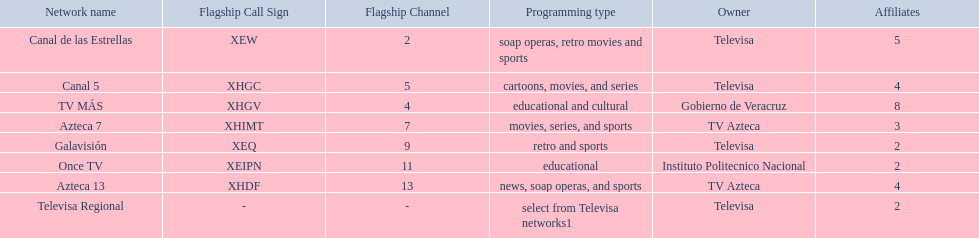Which owner has the most networks? Televisa. Parse the table in full. {'header': ['Network name', 'Flagship Call Sign', 'Flagship Channel', 'Programming type', 'Owner', 'Affiliates'], 'rows': [['Canal de las Estrellas', 'XEW', '2', 'soap operas, retro movies and sports', 'Televisa', '5'], ['Canal 5', 'XHGC', '5', 'cartoons, movies, and series', 'Televisa', '4'], ['TV MÁS', 'XHGV', '4', 'educational and cultural', 'Gobierno de Veracruz', '8'], ['Azteca 7', 'XHIMT', '7', 'movies, series, and sports', 'TV Azteca', '3'], ['Galavisión', 'XEQ', '9', 'retro and sports', 'Televisa', '2'], ['Once TV', 'XEIPN', '11', 'educational', 'Instituto Politecnico Nacional', '2'], ['Azteca 13', 'XHDF', '13', 'news, soap operas, and sports', 'TV Azteca', '4'], ['Televisa Regional', '-', '-', 'select from Televisa networks1', 'Televisa', '2']]} 